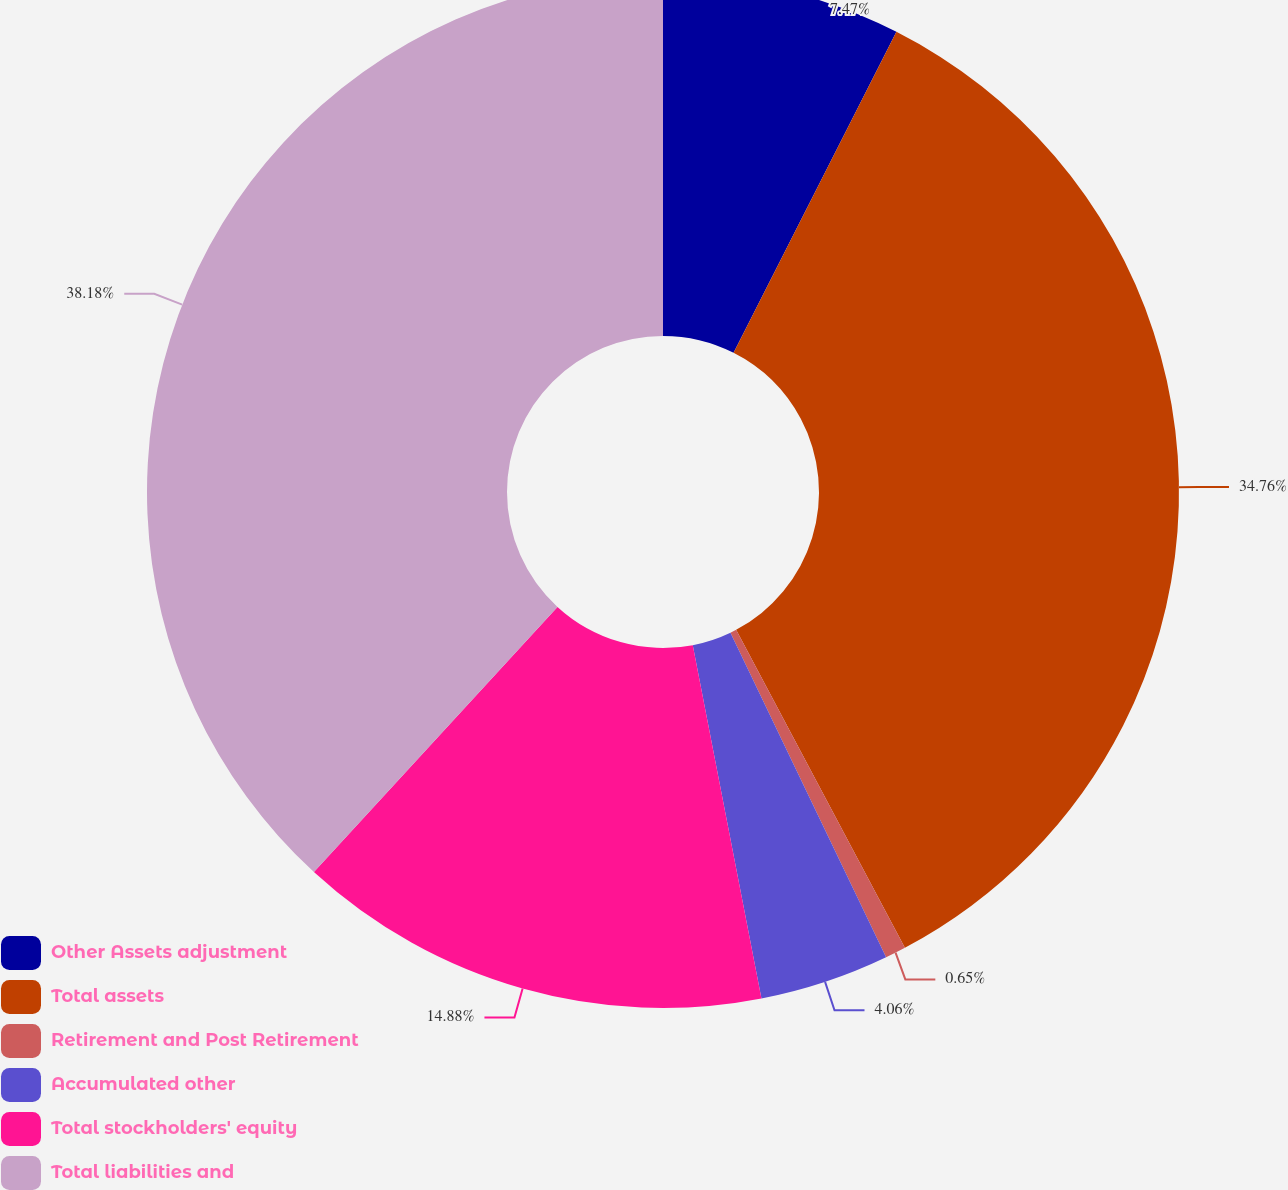<chart> <loc_0><loc_0><loc_500><loc_500><pie_chart><fcel>Other Assets adjustment<fcel>Total assets<fcel>Retirement and Post Retirement<fcel>Accumulated other<fcel>Total stockholders' equity<fcel>Total liabilities and<nl><fcel>7.47%<fcel>34.76%<fcel>0.65%<fcel>4.06%<fcel>14.88%<fcel>38.17%<nl></chart> 